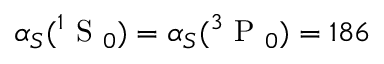<formula> <loc_0><loc_0><loc_500><loc_500>\alpha _ { S } ( ^ { 1 } S _ { 0 } ) = \alpha _ { S } ( ^ { 3 } P _ { 0 } ) = 1 8 6</formula> 